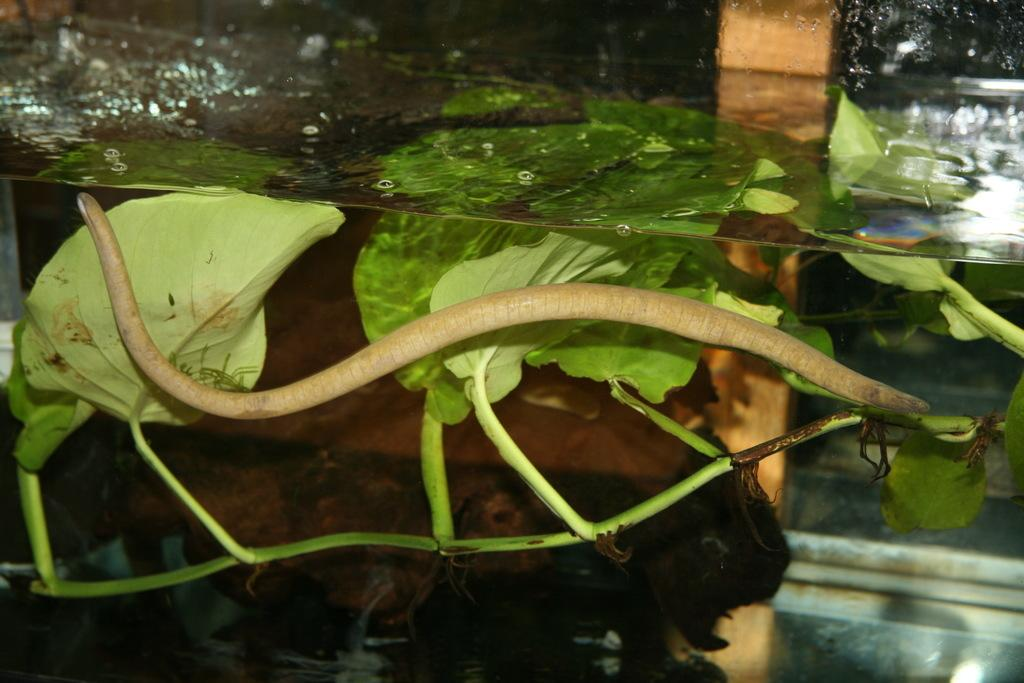What is the main object in the image that resembles an aquarium? There is an object in the image that resembles an aquarium. What can be found inside the aquarium-like object? There is a plant in the water and an object that resembles a snake in the water. Are there any other objects in the water? Yes, there are two additional objects in the water. How many dolls can be seen crying near the mailbox in the image? There are no dolls or mailboxes present in the image. 